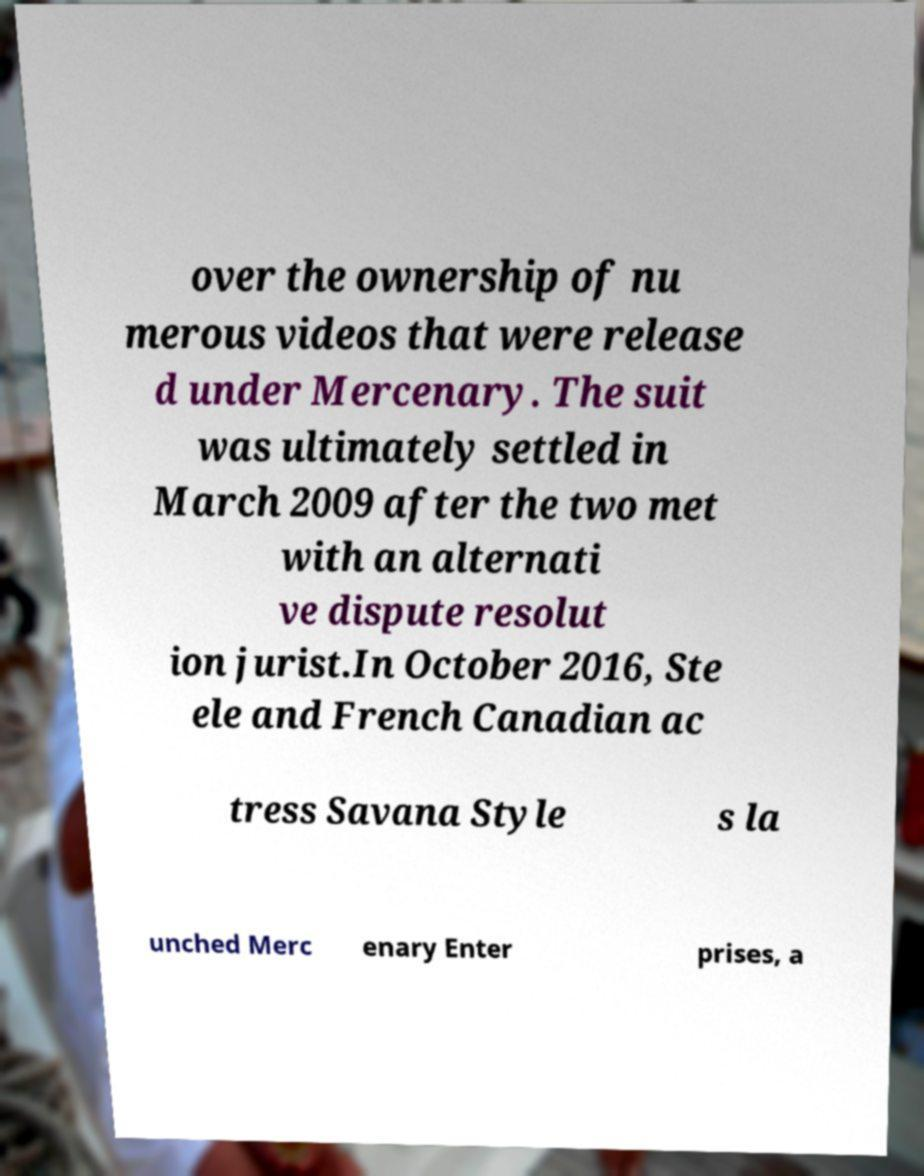I need the written content from this picture converted into text. Can you do that? over the ownership of nu merous videos that were release d under Mercenary. The suit was ultimately settled in March 2009 after the two met with an alternati ve dispute resolut ion jurist.In October 2016, Ste ele and French Canadian ac tress Savana Style s la unched Merc enary Enter prises, a 